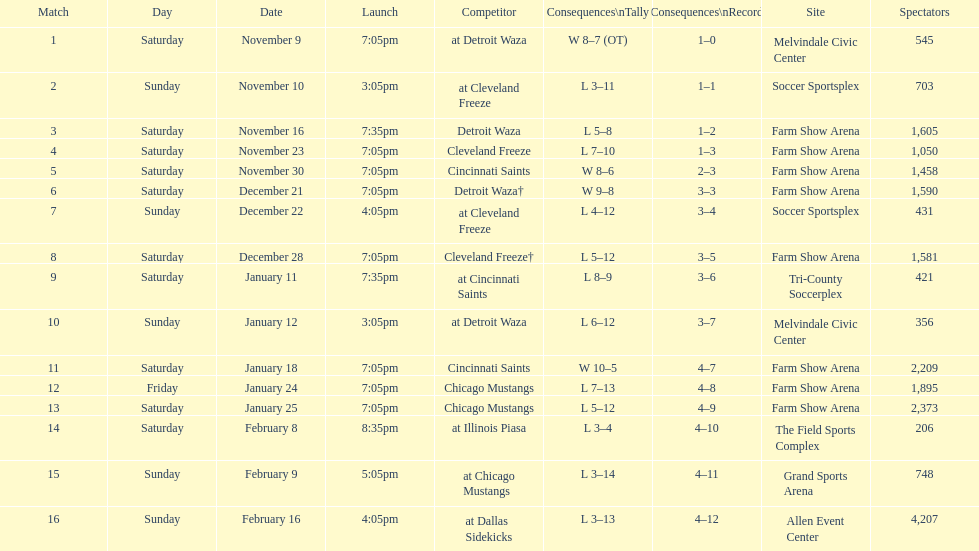How many games did the harrisburg heat win in which they scored eight or more goals? 4. 